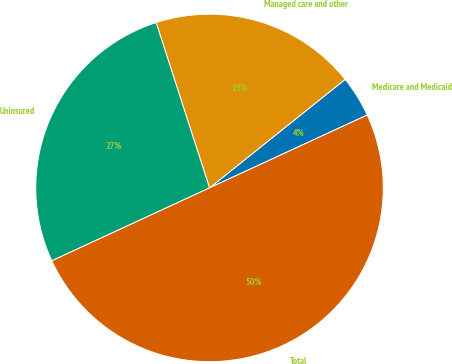Convert chart. <chart><loc_0><loc_0><loc_500><loc_500><pie_chart><fcel>Medicare and Medicaid<fcel>Managed care and other<fcel>Uninsured<fcel>Total<nl><fcel>3.85%<fcel>19.23%<fcel>26.92%<fcel>50.0%<nl></chart> 